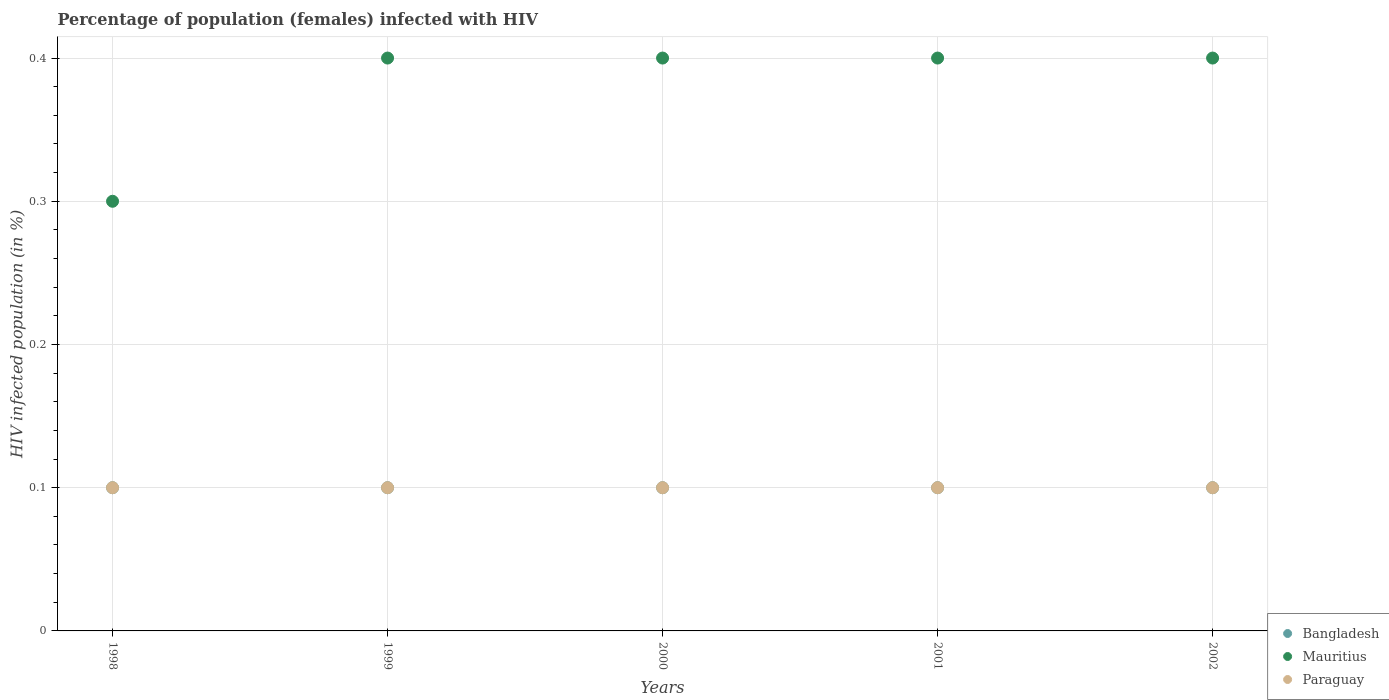How many different coloured dotlines are there?
Your response must be concise. 3. What is the percentage of HIV infected female population in Bangladesh in 2001?
Give a very brief answer. 0.1. What is the total percentage of HIV infected female population in Mauritius in the graph?
Your answer should be compact. 1.9. What is the difference between the percentage of HIV infected female population in Mauritius in 1998 and that in 2001?
Offer a terse response. -0.1. What is the difference between the percentage of HIV infected female population in Mauritius in 2002 and the percentage of HIV infected female population in Bangladesh in 1999?
Your answer should be very brief. 0.3. In the year 2002, what is the difference between the percentage of HIV infected female population in Bangladesh and percentage of HIV infected female population in Paraguay?
Your answer should be compact. 0. What is the ratio of the percentage of HIV infected female population in Bangladesh in 1999 to that in 2001?
Keep it short and to the point. 1. Is the percentage of HIV infected female population in Mauritius in 2001 less than that in 2002?
Offer a terse response. No. Is the difference between the percentage of HIV infected female population in Bangladesh in 2001 and 2002 greater than the difference between the percentage of HIV infected female population in Paraguay in 2001 and 2002?
Your answer should be very brief. No. What is the difference between the highest and the lowest percentage of HIV infected female population in Mauritius?
Provide a short and direct response. 0.1. Is the sum of the percentage of HIV infected female population in Bangladesh in 1999 and 2000 greater than the maximum percentage of HIV infected female population in Mauritius across all years?
Offer a terse response. No. Does the percentage of HIV infected female population in Bangladesh monotonically increase over the years?
Offer a very short reply. No. How many dotlines are there?
Make the answer very short. 3. What is the difference between two consecutive major ticks on the Y-axis?
Offer a very short reply. 0.1. Are the values on the major ticks of Y-axis written in scientific E-notation?
Offer a terse response. No. Does the graph contain grids?
Your answer should be very brief. Yes. How are the legend labels stacked?
Keep it short and to the point. Vertical. What is the title of the graph?
Your response must be concise. Percentage of population (females) infected with HIV. What is the label or title of the Y-axis?
Offer a terse response. HIV infected population (in %). What is the HIV infected population (in %) of Bangladesh in 1998?
Your response must be concise. 0.1. What is the HIV infected population (in %) in Mauritius in 1998?
Offer a terse response. 0.3. What is the HIV infected population (in %) in Paraguay in 1998?
Give a very brief answer. 0.1. What is the HIV infected population (in %) of Bangladesh in 1999?
Your answer should be very brief. 0.1. What is the HIV infected population (in %) in Paraguay in 1999?
Your response must be concise. 0.1. What is the HIV infected population (in %) of Mauritius in 2001?
Your answer should be compact. 0.4. What is the HIV infected population (in %) of Bangladesh in 2002?
Keep it short and to the point. 0.1. What is the HIV infected population (in %) of Paraguay in 2002?
Provide a succinct answer. 0.1. Across all years, what is the maximum HIV infected population (in %) in Bangladesh?
Provide a short and direct response. 0.1. Across all years, what is the maximum HIV infected population (in %) in Mauritius?
Your answer should be compact. 0.4. Across all years, what is the minimum HIV infected population (in %) in Bangladesh?
Your response must be concise. 0.1. Across all years, what is the minimum HIV infected population (in %) of Mauritius?
Keep it short and to the point. 0.3. What is the total HIV infected population (in %) in Mauritius in the graph?
Keep it short and to the point. 1.9. What is the total HIV infected population (in %) of Paraguay in the graph?
Offer a very short reply. 0.5. What is the difference between the HIV infected population (in %) of Bangladesh in 1998 and that in 1999?
Give a very brief answer. 0. What is the difference between the HIV infected population (in %) of Paraguay in 1998 and that in 1999?
Keep it short and to the point. 0. What is the difference between the HIV infected population (in %) in Bangladesh in 1998 and that in 2000?
Your response must be concise. 0. What is the difference between the HIV infected population (in %) in Mauritius in 1998 and that in 2000?
Your answer should be very brief. -0.1. What is the difference between the HIV infected population (in %) of Bangladesh in 1998 and that in 2001?
Make the answer very short. 0. What is the difference between the HIV infected population (in %) in Mauritius in 1998 and that in 2002?
Your response must be concise. -0.1. What is the difference between the HIV infected population (in %) in Bangladesh in 1999 and that in 2001?
Provide a succinct answer. 0. What is the difference between the HIV infected population (in %) of Bangladesh in 1999 and that in 2002?
Offer a very short reply. 0. What is the difference between the HIV infected population (in %) in Paraguay in 1999 and that in 2002?
Offer a very short reply. 0. What is the difference between the HIV infected population (in %) of Bangladesh in 2000 and that in 2001?
Your response must be concise. 0. What is the difference between the HIV infected population (in %) of Paraguay in 2000 and that in 2001?
Provide a short and direct response. 0. What is the difference between the HIV infected population (in %) in Bangladesh in 2000 and that in 2002?
Your response must be concise. 0. What is the difference between the HIV infected population (in %) of Mauritius in 2000 and that in 2002?
Your answer should be compact. 0. What is the difference between the HIV infected population (in %) in Bangladesh in 2001 and that in 2002?
Offer a very short reply. 0. What is the difference between the HIV infected population (in %) of Paraguay in 2001 and that in 2002?
Your answer should be compact. 0. What is the difference between the HIV infected population (in %) in Bangladesh in 1998 and the HIV infected population (in %) in Mauritius in 2000?
Your answer should be very brief. -0.3. What is the difference between the HIV infected population (in %) in Bangladesh in 1998 and the HIV infected population (in %) in Paraguay in 2001?
Make the answer very short. 0. What is the difference between the HIV infected population (in %) in Mauritius in 1998 and the HIV infected population (in %) in Paraguay in 2001?
Offer a very short reply. 0.2. What is the difference between the HIV infected population (in %) in Bangladesh in 1998 and the HIV infected population (in %) in Mauritius in 2002?
Your answer should be compact. -0.3. What is the difference between the HIV infected population (in %) of Mauritius in 1998 and the HIV infected population (in %) of Paraguay in 2002?
Offer a very short reply. 0.2. What is the difference between the HIV infected population (in %) of Bangladesh in 1999 and the HIV infected population (in %) of Mauritius in 2000?
Your answer should be compact. -0.3. What is the difference between the HIV infected population (in %) of Bangladesh in 1999 and the HIV infected population (in %) of Mauritius in 2001?
Your response must be concise. -0.3. What is the difference between the HIV infected population (in %) of Bangladesh in 1999 and the HIV infected population (in %) of Paraguay in 2002?
Provide a short and direct response. 0. What is the difference between the HIV infected population (in %) in Mauritius in 2000 and the HIV infected population (in %) in Paraguay in 2001?
Make the answer very short. 0.3. What is the difference between the HIV infected population (in %) of Bangladesh in 2000 and the HIV infected population (in %) of Mauritius in 2002?
Your answer should be compact. -0.3. What is the difference between the HIV infected population (in %) of Bangladesh in 2000 and the HIV infected population (in %) of Paraguay in 2002?
Offer a very short reply. 0. What is the difference between the HIV infected population (in %) of Bangladesh in 2001 and the HIV infected population (in %) of Paraguay in 2002?
Provide a short and direct response. 0. What is the difference between the HIV infected population (in %) in Mauritius in 2001 and the HIV infected population (in %) in Paraguay in 2002?
Your answer should be compact. 0.3. What is the average HIV infected population (in %) in Mauritius per year?
Your response must be concise. 0.38. What is the average HIV infected population (in %) in Paraguay per year?
Keep it short and to the point. 0.1. In the year 1998, what is the difference between the HIV infected population (in %) of Bangladesh and HIV infected population (in %) of Paraguay?
Give a very brief answer. 0. In the year 1998, what is the difference between the HIV infected population (in %) of Mauritius and HIV infected population (in %) of Paraguay?
Give a very brief answer. 0.2. In the year 2000, what is the difference between the HIV infected population (in %) of Bangladesh and HIV infected population (in %) of Paraguay?
Your answer should be compact. 0. In the year 2001, what is the difference between the HIV infected population (in %) in Mauritius and HIV infected population (in %) in Paraguay?
Keep it short and to the point. 0.3. In the year 2002, what is the difference between the HIV infected population (in %) of Bangladesh and HIV infected population (in %) of Paraguay?
Your answer should be compact. 0. In the year 2002, what is the difference between the HIV infected population (in %) of Mauritius and HIV infected population (in %) of Paraguay?
Provide a succinct answer. 0.3. What is the ratio of the HIV infected population (in %) of Mauritius in 1998 to that in 1999?
Ensure brevity in your answer.  0.75. What is the ratio of the HIV infected population (in %) in Paraguay in 1998 to that in 1999?
Give a very brief answer. 1. What is the ratio of the HIV infected population (in %) of Bangladesh in 1998 to that in 2000?
Your response must be concise. 1. What is the ratio of the HIV infected population (in %) in Mauritius in 1998 to that in 2000?
Your answer should be very brief. 0.75. What is the ratio of the HIV infected population (in %) in Paraguay in 1998 to that in 2000?
Provide a short and direct response. 1. What is the ratio of the HIV infected population (in %) in Bangladesh in 1998 to that in 2001?
Offer a terse response. 1. What is the ratio of the HIV infected population (in %) of Mauritius in 1998 to that in 2001?
Make the answer very short. 0.75. What is the ratio of the HIV infected population (in %) of Paraguay in 1998 to that in 2001?
Your answer should be compact. 1. What is the ratio of the HIV infected population (in %) in Bangladesh in 1998 to that in 2002?
Offer a very short reply. 1. What is the ratio of the HIV infected population (in %) of Mauritius in 1998 to that in 2002?
Provide a short and direct response. 0.75. What is the ratio of the HIV infected population (in %) of Paraguay in 1998 to that in 2002?
Give a very brief answer. 1. What is the ratio of the HIV infected population (in %) in Bangladesh in 1999 to that in 2000?
Give a very brief answer. 1. What is the ratio of the HIV infected population (in %) of Mauritius in 1999 to that in 2000?
Offer a terse response. 1. What is the ratio of the HIV infected population (in %) in Paraguay in 1999 to that in 2000?
Offer a very short reply. 1. What is the ratio of the HIV infected population (in %) of Bangladesh in 1999 to that in 2001?
Provide a succinct answer. 1. What is the ratio of the HIV infected population (in %) of Mauritius in 1999 to that in 2001?
Give a very brief answer. 1. What is the ratio of the HIV infected population (in %) in Paraguay in 1999 to that in 2001?
Your answer should be compact. 1. What is the ratio of the HIV infected population (in %) in Bangladesh in 1999 to that in 2002?
Ensure brevity in your answer.  1. What is the ratio of the HIV infected population (in %) of Mauritius in 1999 to that in 2002?
Ensure brevity in your answer.  1. What is the ratio of the HIV infected population (in %) in Bangladesh in 2000 to that in 2001?
Your answer should be very brief. 1. What is the ratio of the HIV infected population (in %) in Mauritius in 2000 to that in 2001?
Offer a terse response. 1. What is the ratio of the HIV infected population (in %) in Paraguay in 2000 to that in 2002?
Ensure brevity in your answer.  1. What is the ratio of the HIV infected population (in %) in Bangladesh in 2001 to that in 2002?
Your answer should be compact. 1. What is the ratio of the HIV infected population (in %) in Paraguay in 2001 to that in 2002?
Offer a very short reply. 1. What is the difference between the highest and the second highest HIV infected population (in %) in Bangladesh?
Offer a terse response. 0. What is the difference between the highest and the second highest HIV infected population (in %) in Mauritius?
Your answer should be very brief. 0. What is the difference between the highest and the second highest HIV infected population (in %) of Paraguay?
Ensure brevity in your answer.  0. 